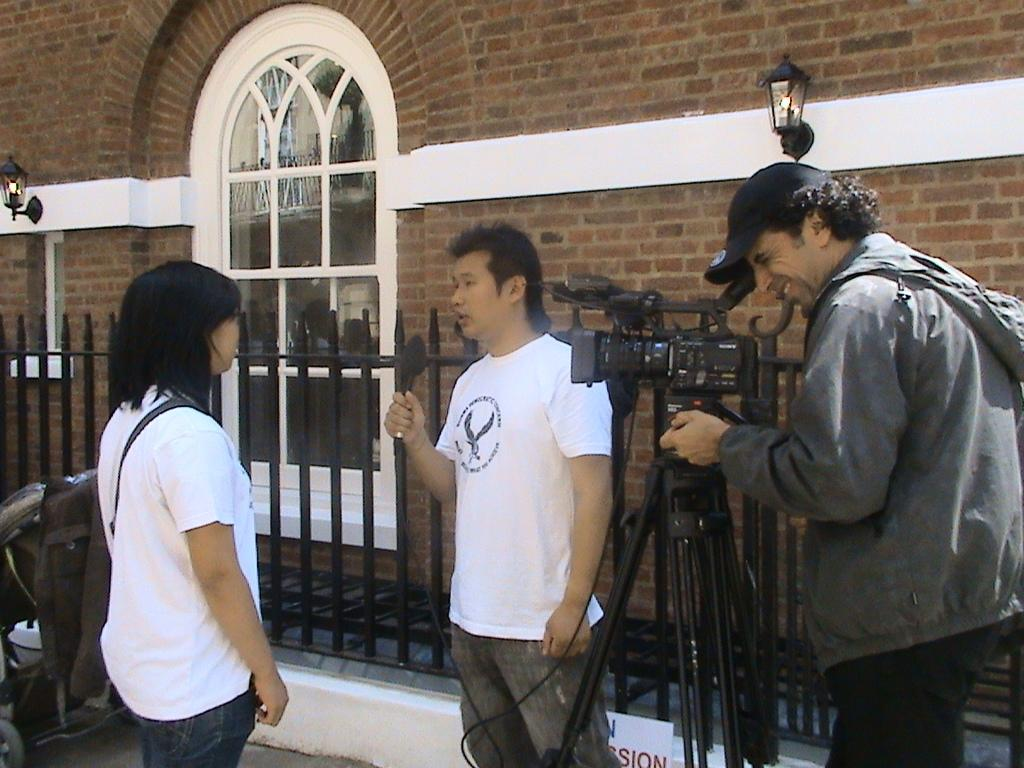How many people are in the image? There are two men and two women in the image. What is one of the men doing in the image? One man is holding a camera. What can be seen in the background of the image? There is a railing and a wall in the background of the image. What feature is present on the wall? There is a window in the wall. What can be seen illuminating the scene? There are lights visible in the image. What type of notebook is being used by the women in the image? There is no notebook present in the image; the women are not shown using any notebooks. What type of harmony is being played by the group in the image? There is no indication of music or harmony in the image; the people are not shown playing any instruments or singing. 